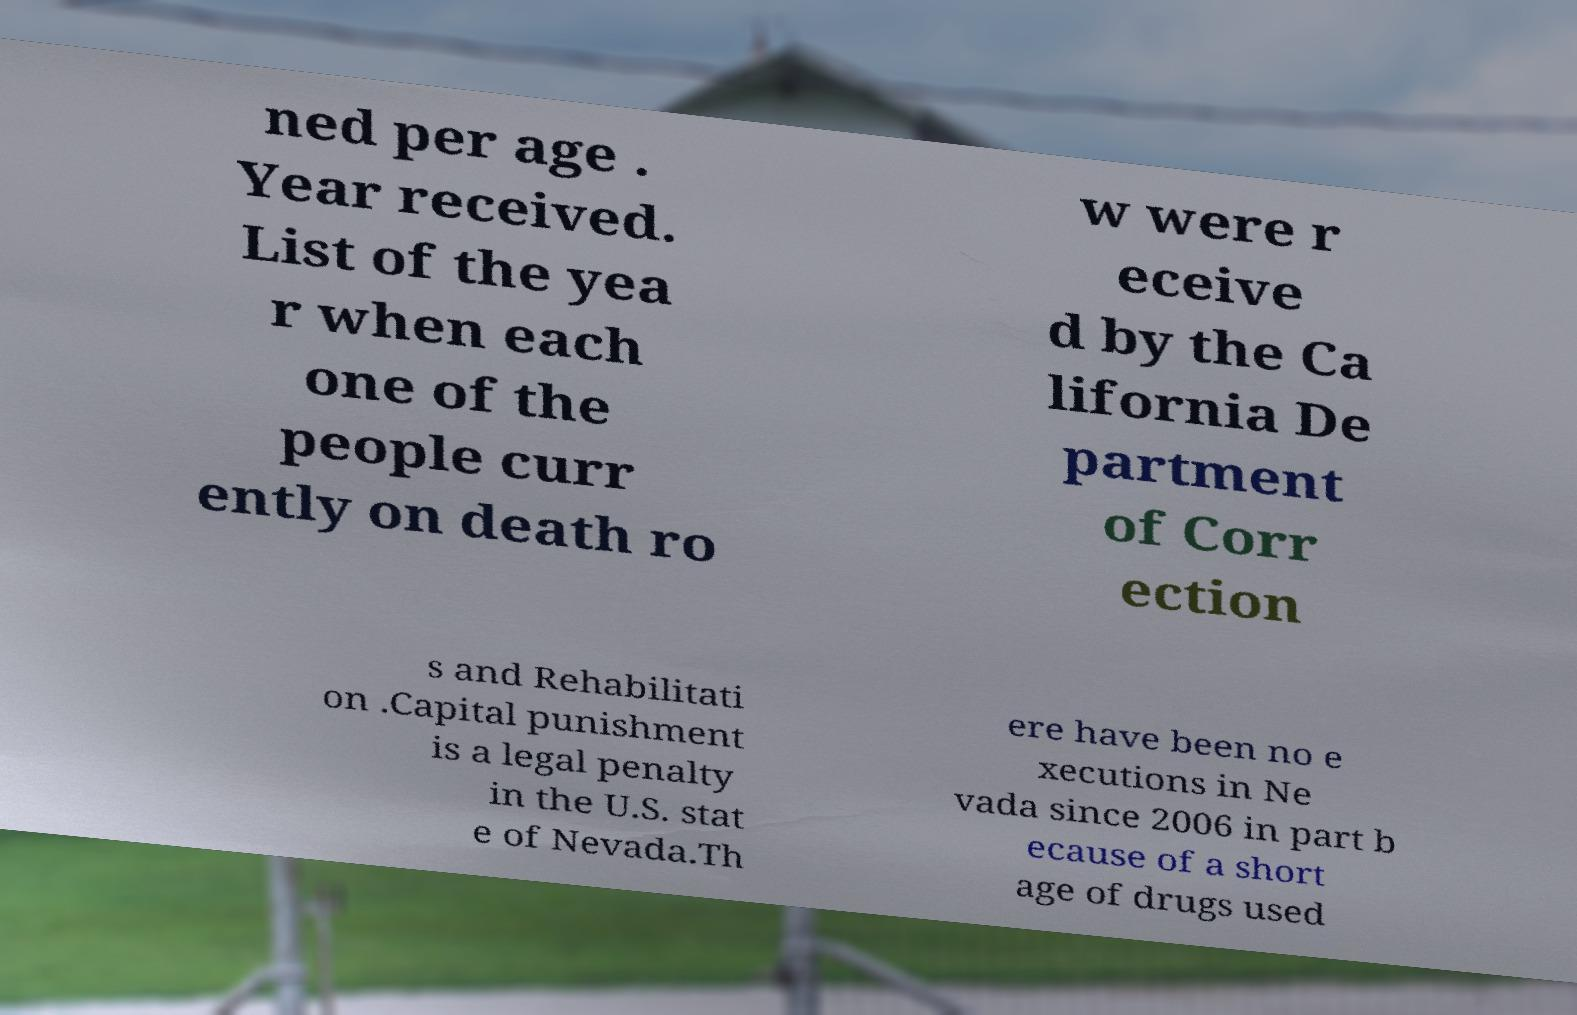Could you assist in decoding the text presented in this image and type it out clearly? ned per age . Year received. List of the yea r when each one of the people curr ently on death ro w were r eceive d by the Ca lifornia De partment of Corr ection s and Rehabilitati on .Capital punishment is a legal penalty in the U.S. stat e of Nevada.Th ere have been no e xecutions in Ne vada since 2006 in part b ecause of a short age of drugs used 